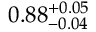Convert formula to latex. <formula><loc_0><loc_0><loc_500><loc_500>0 . 8 8 _ { - 0 . 0 4 } ^ { + 0 . 0 5 }</formula> 